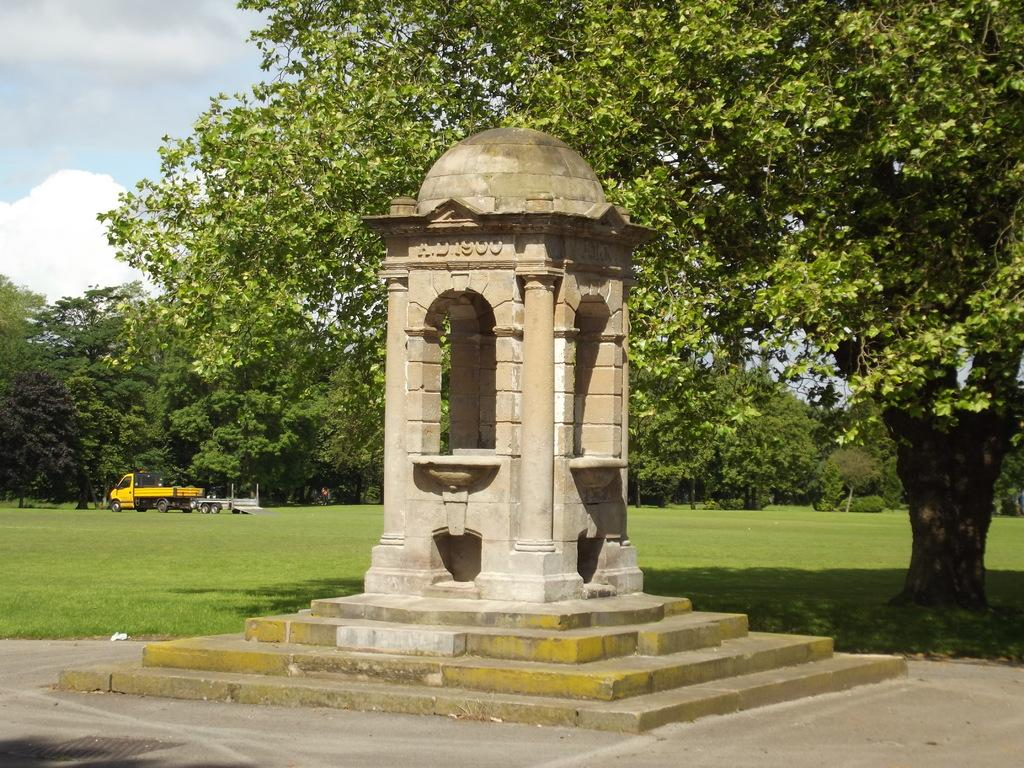What is the main subject of the image? There is a memorial in the image. What can be seen at the top of the image? There is a tree and the sky visible at the top of the image. Where is the vehicle located in the image? The vehicle is on the left side of the image. How many sisters are depicted in the memorial in the image? There is no mention of sisters in the image, as it features a memorial and other elements. 